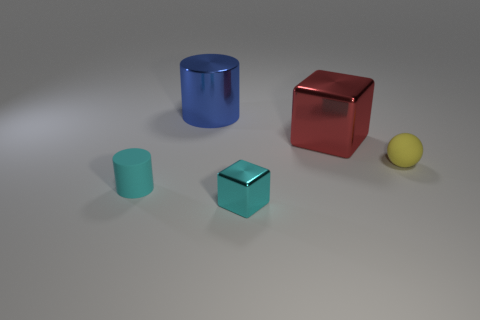How many other objects are there of the same color as the small shiny cube?
Keep it short and to the point. 1. There is a tiny thing that is both left of the red thing and right of the tiny cyan cylinder; what is its color?
Make the answer very short. Cyan. Are the large object behind the large metallic cube and the cube that is behind the tiny yellow ball made of the same material?
Your answer should be compact. Yes. Are there more large red metallic things that are to the right of the large red metallic object than large red blocks that are behind the large blue metal cylinder?
Give a very brief answer. No. There is a yellow rubber thing that is the same size as the cyan rubber object; what shape is it?
Offer a very short reply. Sphere. What number of things are either large purple metal balls or cylinders behind the cyan cylinder?
Your answer should be compact. 1. Does the small metallic cube have the same color as the sphere?
Offer a terse response. No. There is a tiny rubber sphere; what number of tiny matte objects are on the left side of it?
Offer a very short reply. 1. There is a large block that is made of the same material as the large cylinder; what is its color?
Your answer should be compact. Red. What number of shiny things are yellow things or tiny purple cylinders?
Provide a succinct answer. 0. 